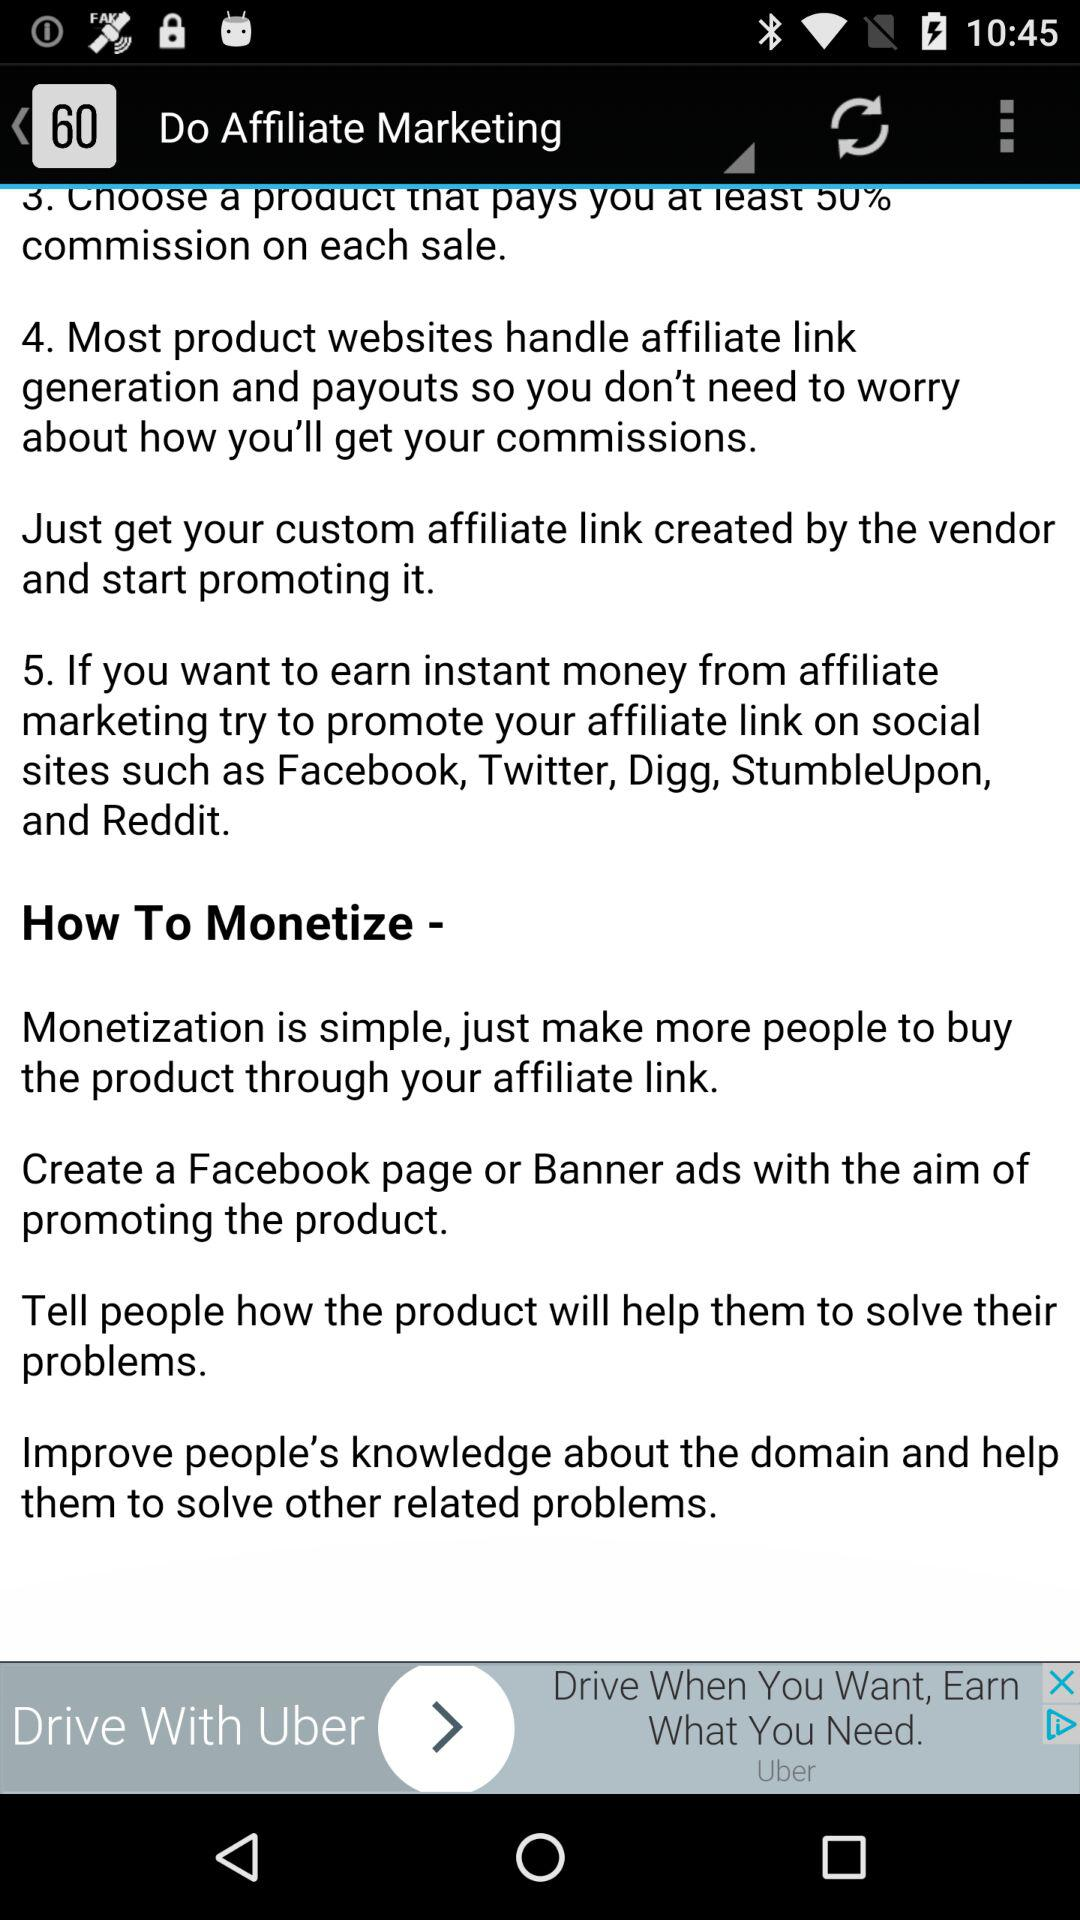How many steps are there in the affiliate marketing process?
Answer the question using a single word or phrase. 5 